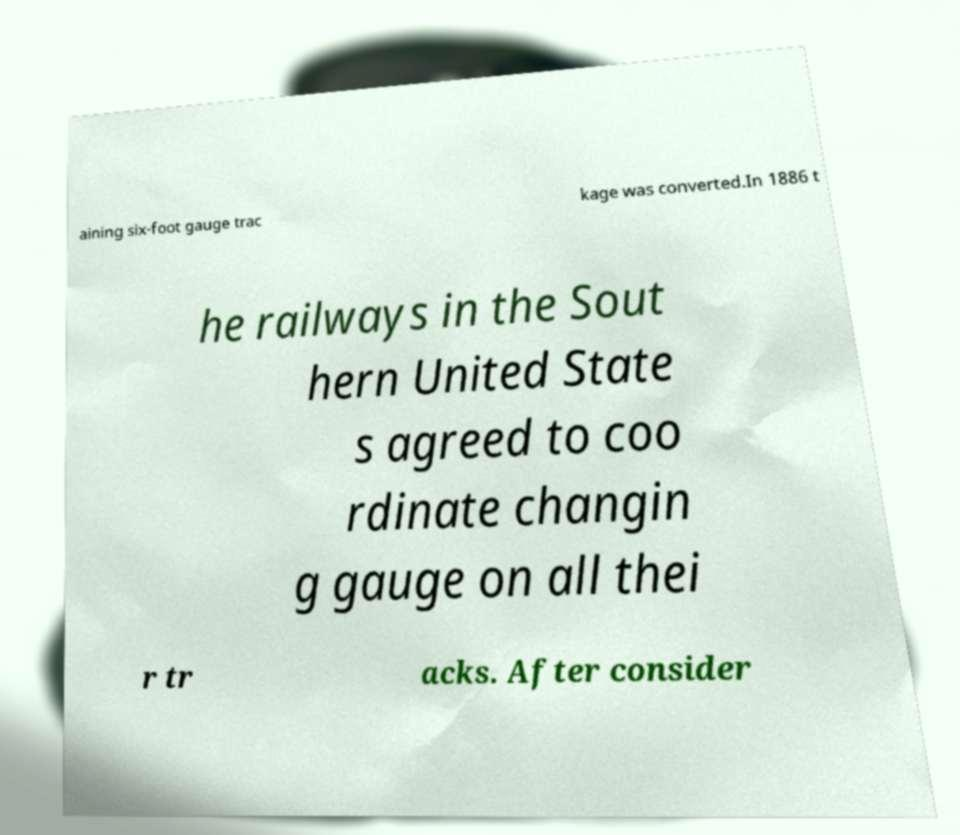I need the written content from this picture converted into text. Can you do that? aining six-foot gauge trac kage was converted.In 1886 t he railways in the Sout hern United State s agreed to coo rdinate changin g gauge on all thei r tr acks. After consider 